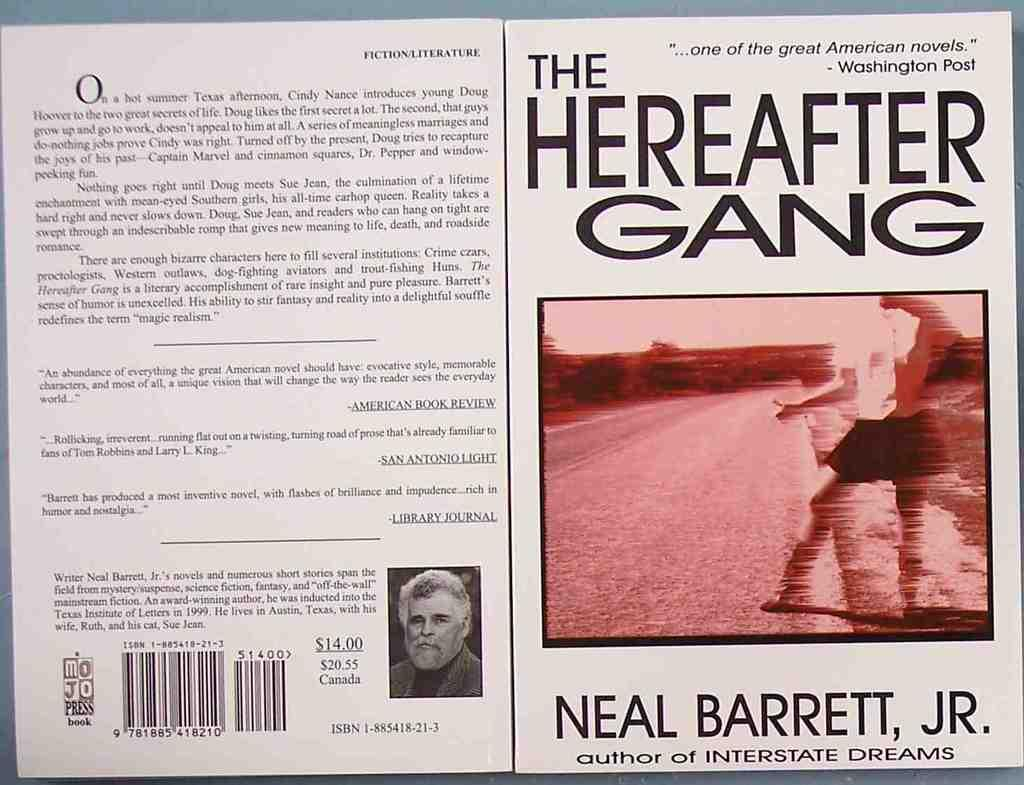<image>
Describe the image concisely. A cover of The Hereafter Gang written by Neal Barrett, Jr. 